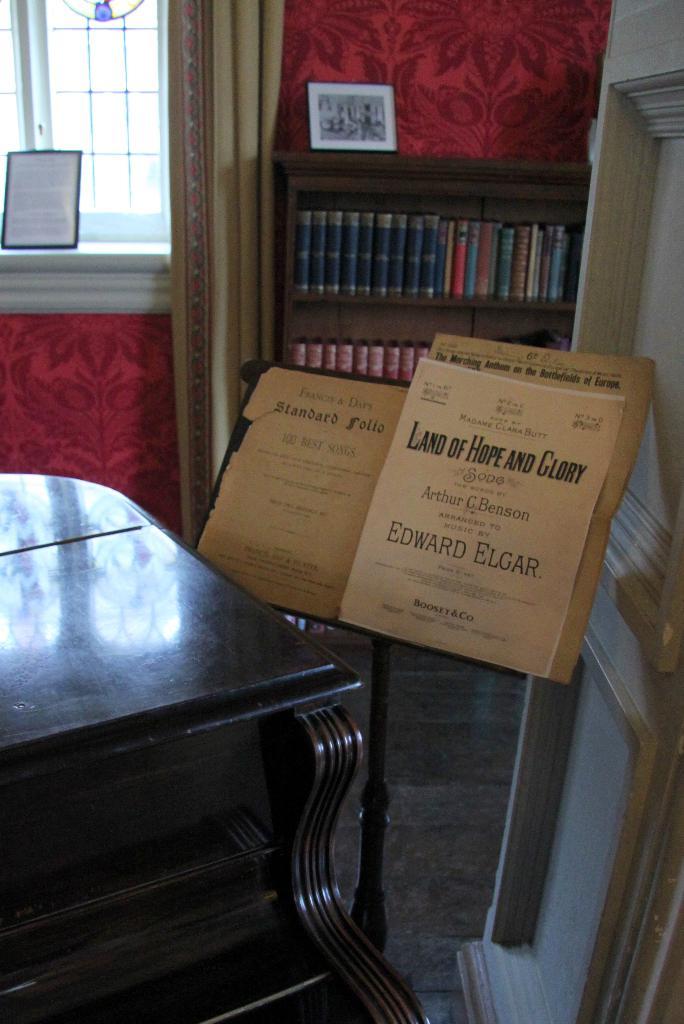Who wrote the book?
Ensure brevity in your answer.  Edward elgar. 